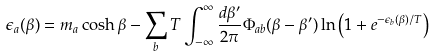Convert formula to latex. <formula><loc_0><loc_0><loc_500><loc_500>\epsilon _ { a } ( \beta ) = { m _ { a } } \cosh \beta - \sum _ { b } T \int _ { - \infty } ^ { \infty } \frac { d \beta ^ { \prime } } { 2 \pi } \Phi _ { a b } ( \beta - \beta ^ { \prime } ) \ln \left ( 1 + e ^ { - \epsilon _ { b } ( \beta ) / T } \right )</formula> 